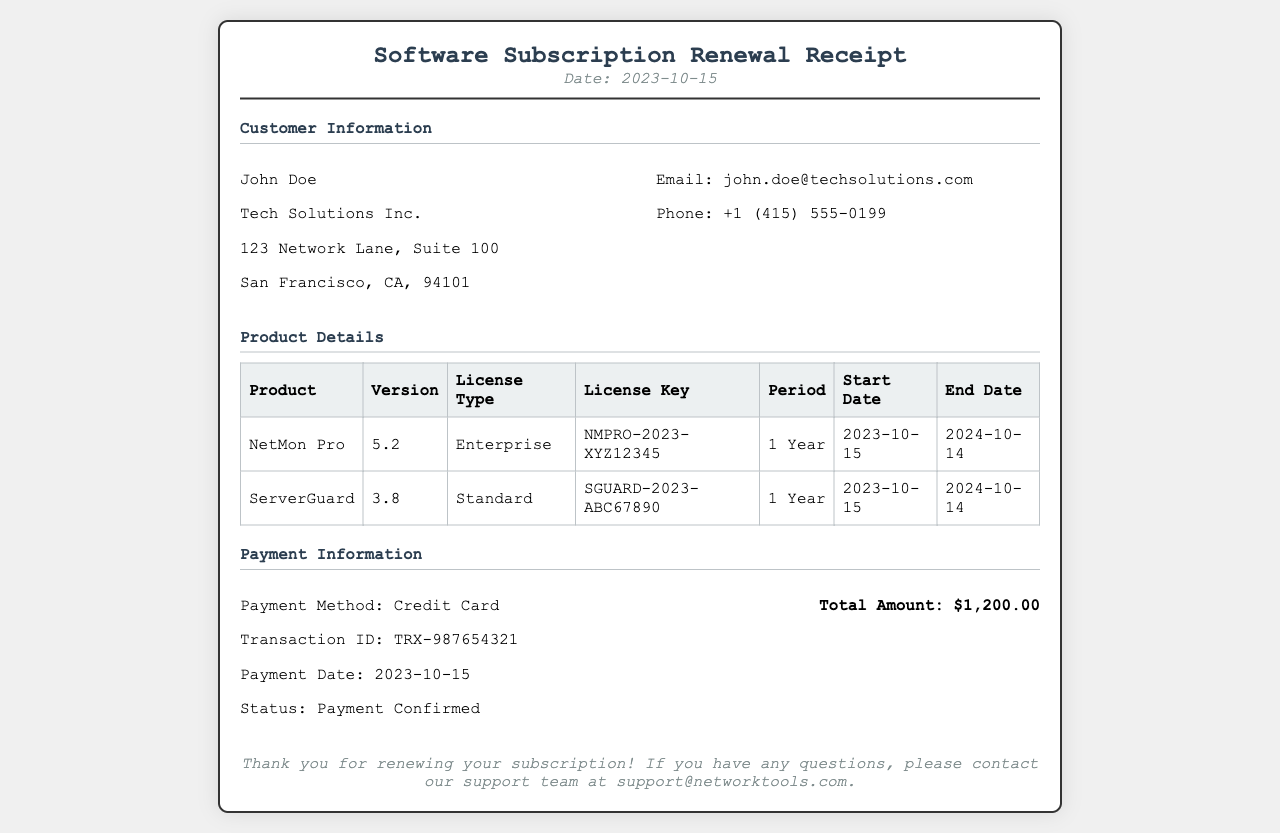What is the date of the receipt? The date mentioned in the receipt is the date when the software subscription was renewed.
Answer: 2023-10-15 Who is the customer? The receipt provides the name of the individual or organization who purchased the subscription.
Answer: John Doe What is the email of the customer? The receipt includes the contact information of the customer, specifically their email address.
Answer: john.doe@techsolutions.com What is the total amount charged? The total amount is shown in the payment information section of the receipt.
Answer: $1,200.00 What is the license key for NetMon Pro? The license key is specified for the product in the product details table.
Answer: NMPRO-2023-XYZ12345 How long is the subscription period for ServerGuard? The receipt states the subscription duration for the server monitoring tool in the product details.
Answer: 1 Year What is the payment method used? The method of payment is provided in the payment information section of the receipt.
Answer: Credit Card What is the transaction ID for the payment? The transaction ID is a unique identifier provided for tracking the specific payment.
Answer: TRX-987654321 Which product has the latest version? The version information for each product is listed, allowing for comparison to determine the latest.
Answer: NetMon Pro 